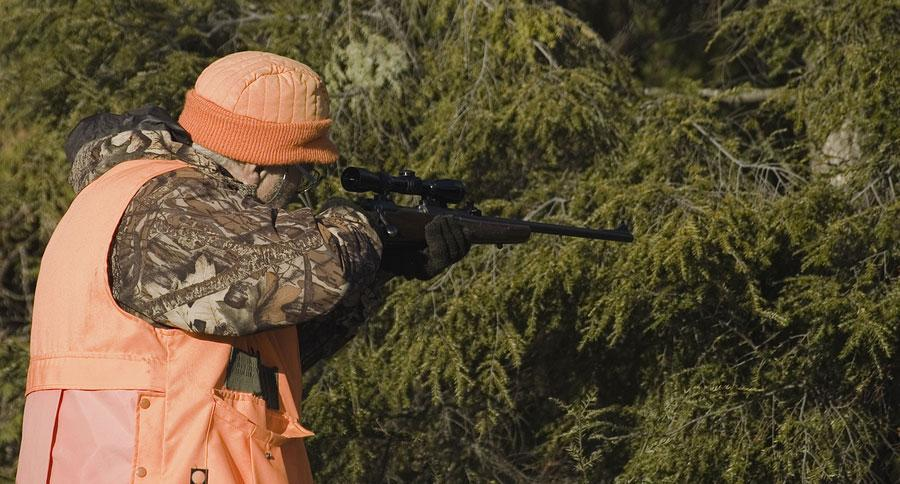how many guns are visible
Answer the question with a short phrase. 1 what is the colour of the gun, black or white black 